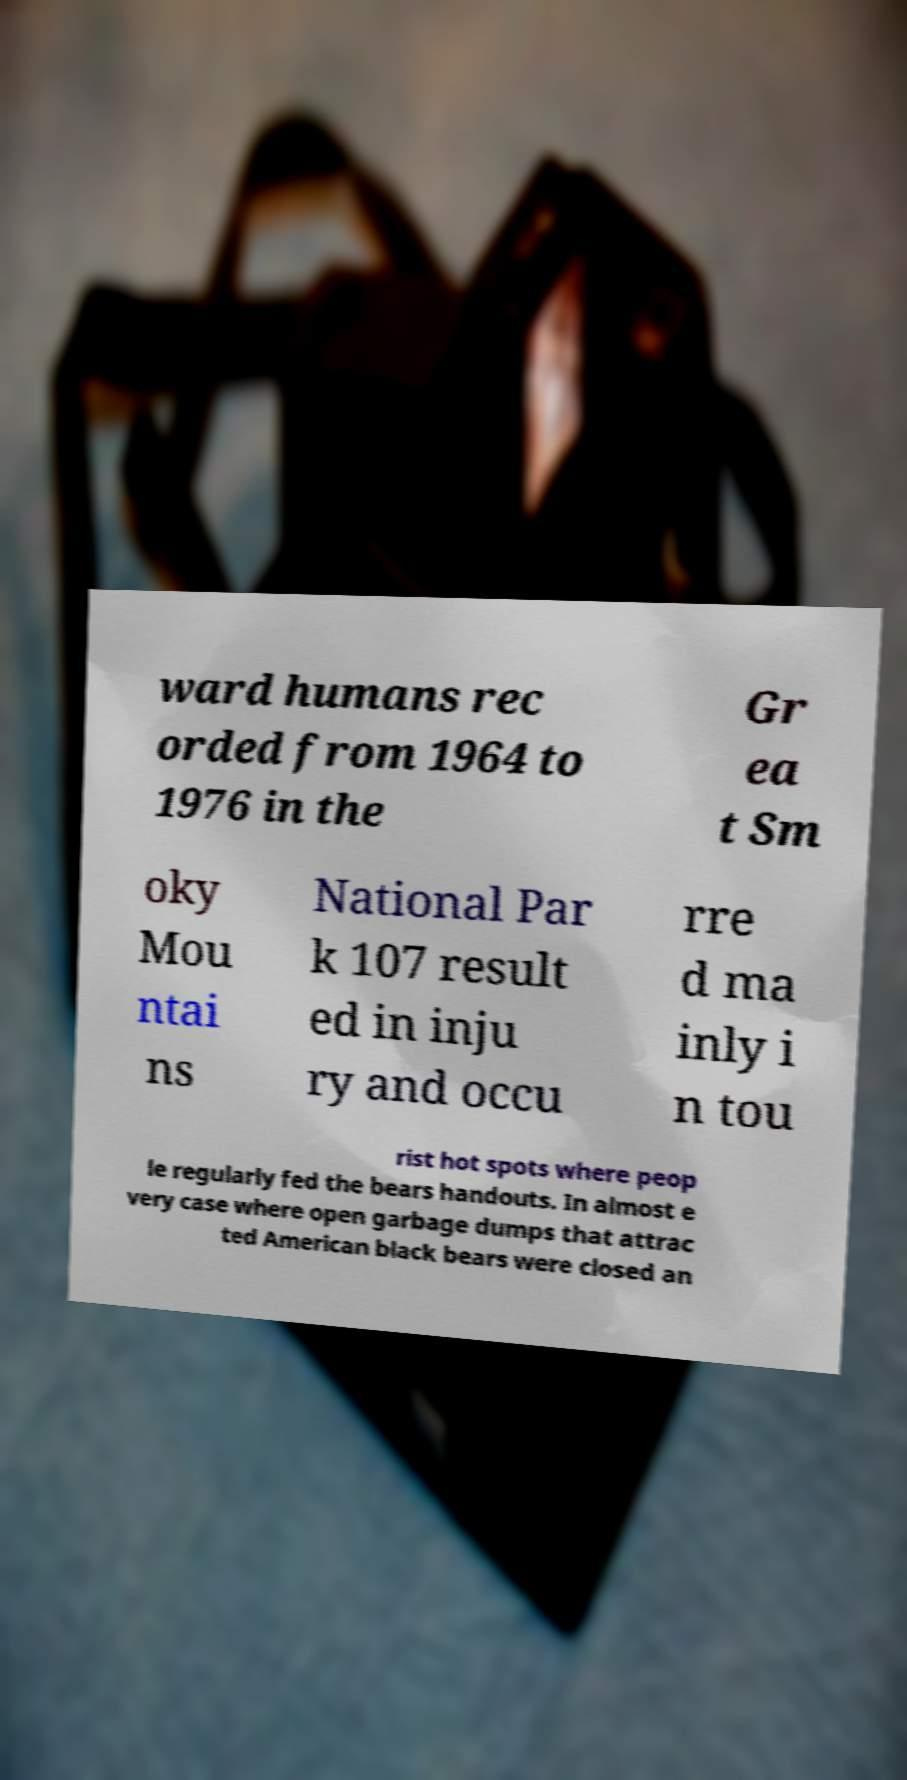Please identify and transcribe the text found in this image. ward humans rec orded from 1964 to 1976 in the Gr ea t Sm oky Mou ntai ns National Par k 107 result ed in inju ry and occu rre d ma inly i n tou rist hot spots where peop le regularly fed the bears handouts. In almost e very case where open garbage dumps that attrac ted American black bears were closed an 